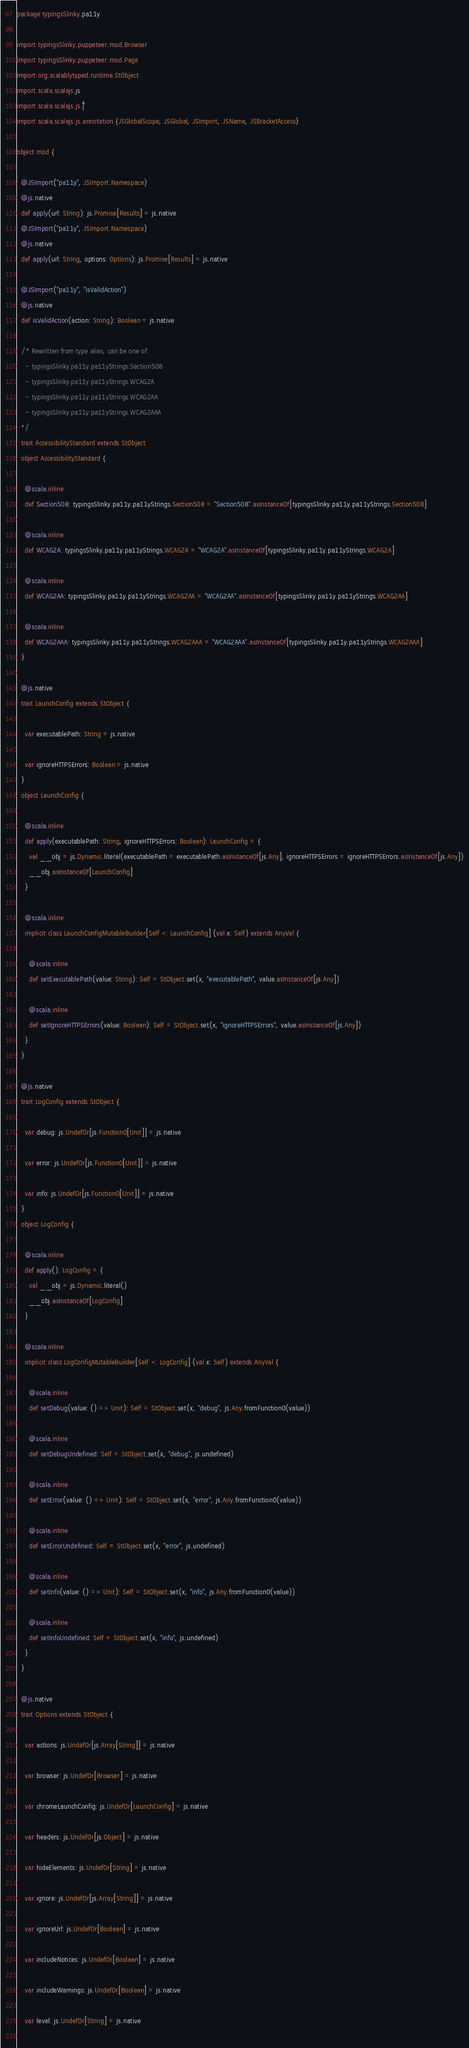Convert code to text. <code><loc_0><loc_0><loc_500><loc_500><_Scala_>package typingsSlinky.pa11y

import typingsSlinky.puppeteer.mod.Browser
import typingsSlinky.puppeteer.mod.Page
import org.scalablytyped.runtime.StObject
import scala.scalajs.js
import scala.scalajs.js.`|`
import scala.scalajs.js.annotation.{JSGlobalScope, JSGlobal, JSImport, JSName, JSBracketAccess}

object mod {
  
  @JSImport("pa11y", JSImport.Namespace)
  @js.native
  def apply(url: String): js.Promise[Results] = js.native
  @JSImport("pa11y", JSImport.Namespace)
  @js.native
  def apply(url: String, options: Options): js.Promise[Results] = js.native
  
  @JSImport("pa11y", "isValidAction")
  @js.native
  def isValidAction(action: String): Boolean = js.native
  
  /* Rewritten from type alias, can be one of: 
    - typingsSlinky.pa11y.pa11yStrings.Section508
    - typingsSlinky.pa11y.pa11yStrings.WCAG2A
    - typingsSlinky.pa11y.pa11yStrings.WCAG2AA
    - typingsSlinky.pa11y.pa11yStrings.WCAG2AAA
  */
  trait AccessibilityStandard extends StObject
  object AccessibilityStandard {
    
    @scala.inline
    def Section508: typingsSlinky.pa11y.pa11yStrings.Section508 = "Section508".asInstanceOf[typingsSlinky.pa11y.pa11yStrings.Section508]
    
    @scala.inline
    def WCAG2A: typingsSlinky.pa11y.pa11yStrings.WCAG2A = "WCAG2A".asInstanceOf[typingsSlinky.pa11y.pa11yStrings.WCAG2A]
    
    @scala.inline
    def WCAG2AA: typingsSlinky.pa11y.pa11yStrings.WCAG2AA = "WCAG2AA".asInstanceOf[typingsSlinky.pa11y.pa11yStrings.WCAG2AA]
    
    @scala.inline
    def WCAG2AAA: typingsSlinky.pa11y.pa11yStrings.WCAG2AAA = "WCAG2AAA".asInstanceOf[typingsSlinky.pa11y.pa11yStrings.WCAG2AAA]
  }
  
  @js.native
  trait LaunchConfig extends StObject {
    
    var executablePath: String = js.native
    
    var ignoreHTTPSErrors: Boolean = js.native
  }
  object LaunchConfig {
    
    @scala.inline
    def apply(executablePath: String, ignoreHTTPSErrors: Boolean): LaunchConfig = {
      val __obj = js.Dynamic.literal(executablePath = executablePath.asInstanceOf[js.Any], ignoreHTTPSErrors = ignoreHTTPSErrors.asInstanceOf[js.Any])
      __obj.asInstanceOf[LaunchConfig]
    }
    
    @scala.inline
    implicit class LaunchConfigMutableBuilder[Self <: LaunchConfig] (val x: Self) extends AnyVal {
      
      @scala.inline
      def setExecutablePath(value: String): Self = StObject.set(x, "executablePath", value.asInstanceOf[js.Any])
      
      @scala.inline
      def setIgnoreHTTPSErrors(value: Boolean): Self = StObject.set(x, "ignoreHTTPSErrors", value.asInstanceOf[js.Any])
    }
  }
  
  @js.native
  trait LogConfig extends StObject {
    
    var debug: js.UndefOr[js.Function0[Unit]] = js.native
    
    var error: js.UndefOr[js.Function0[Unit]] = js.native
    
    var info: js.UndefOr[js.Function0[Unit]] = js.native
  }
  object LogConfig {
    
    @scala.inline
    def apply(): LogConfig = {
      val __obj = js.Dynamic.literal()
      __obj.asInstanceOf[LogConfig]
    }
    
    @scala.inline
    implicit class LogConfigMutableBuilder[Self <: LogConfig] (val x: Self) extends AnyVal {
      
      @scala.inline
      def setDebug(value: () => Unit): Self = StObject.set(x, "debug", js.Any.fromFunction0(value))
      
      @scala.inline
      def setDebugUndefined: Self = StObject.set(x, "debug", js.undefined)
      
      @scala.inline
      def setError(value: () => Unit): Self = StObject.set(x, "error", js.Any.fromFunction0(value))
      
      @scala.inline
      def setErrorUndefined: Self = StObject.set(x, "error", js.undefined)
      
      @scala.inline
      def setInfo(value: () => Unit): Self = StObject.set(x, "info", js.Any.fromFunction0(value))
      
      @scala.inline
      def setInfoUndefined: Self = StObject.set(x, "info", js.undefined)
    }
  }
  
  @js.native
  trait Options extends StObject {
    
    var actions: js.UndefOr[js.Array[String]] = js.native
    
    var browser: js.UndefOr[Browser] = js.native
    
    var chromeLaunchConfig: js.UndefOr[LaunchConfig] = js.native
    
    var headers: js.UndefOr[js.Object] = js.native
    
    var hideElements: js.UndefOr[String] = js.native
    
    var ignore: js.UndefOr[js.Array[String]] = js.native
    
    var ignoreUrl: js.UndefOr[Boolean] = js.native
    
    var includeNotices: js.UndefOr[Boolean] = js.native
    
    var includeWarnings: js.UndefOr[Boolean] = js.native
    
    var level: js.UndefOr[String] = js.native
    </code> 